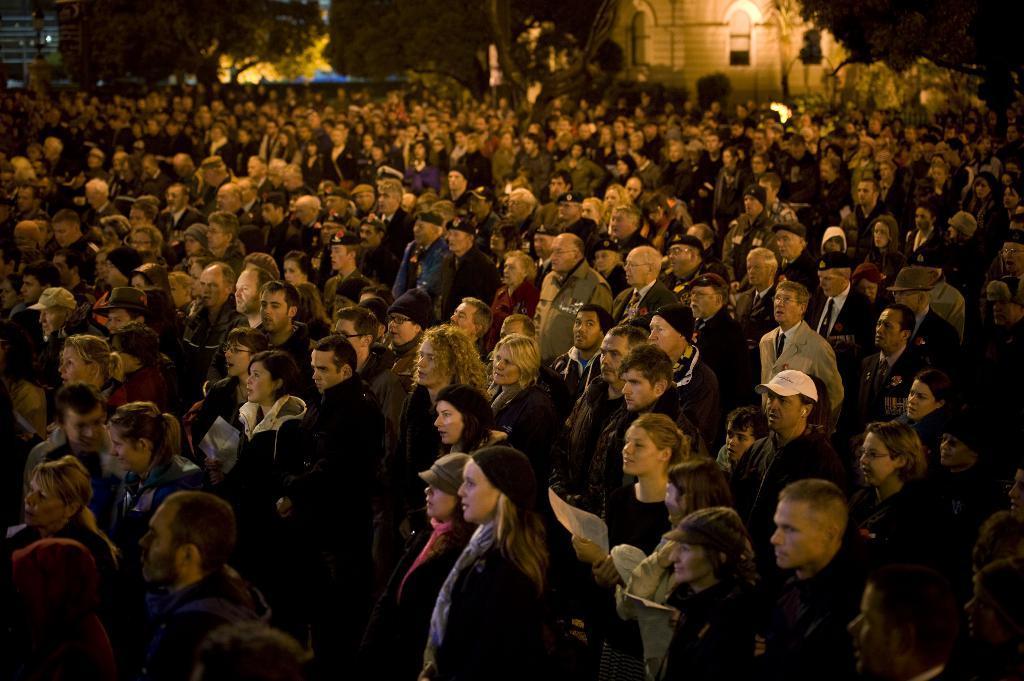Could you give a brief overview of what you see in this image? In the image we can see there are many people around, they are standing, wearing clothes and some of them are wearing caps. Here we can see trees and the buildings. 